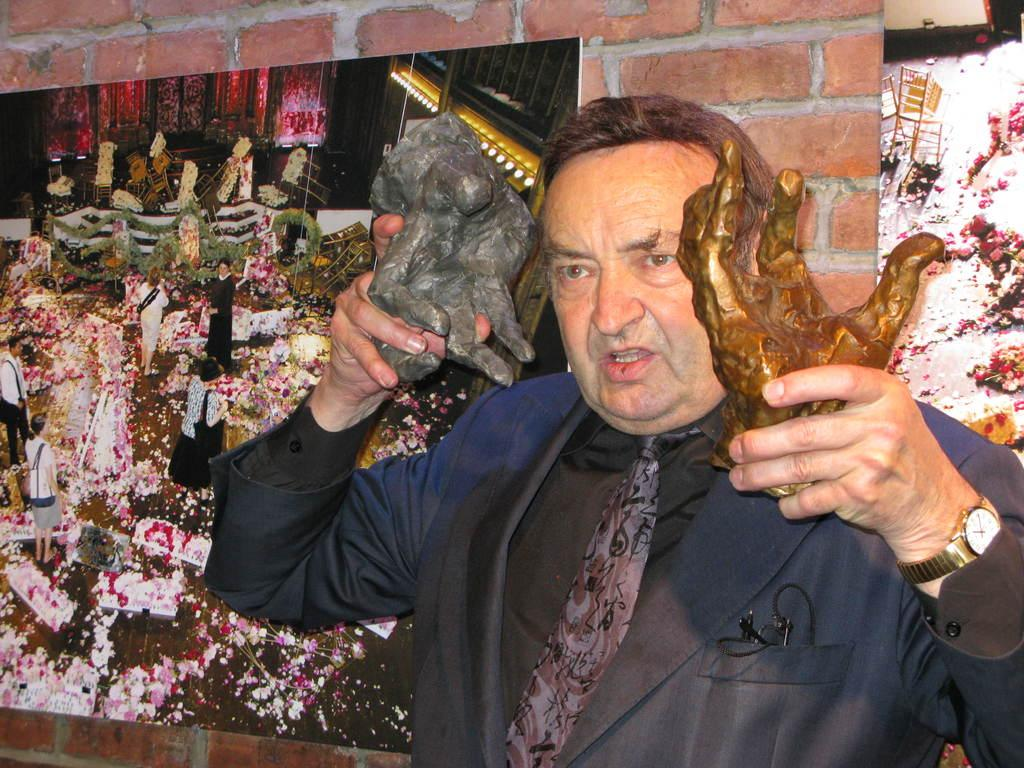What is the main subject of the image? There is a man standing in the image. What is the man holding in the image? The man is holding toy statues. What can be seen in the background of the image? There is a wall in the background of the image. What is placed on the wall in the background? There are frames placed on the wall in the background. What type of planes can be seen flying in the image? There are no planes visible in the image; it features a man holding toy statues with a wall and frames in the background. How many bells are hanging from the frames in the image? There is no mention of bells in the image; it only features a man holding toy statues, a wall, and frames. 